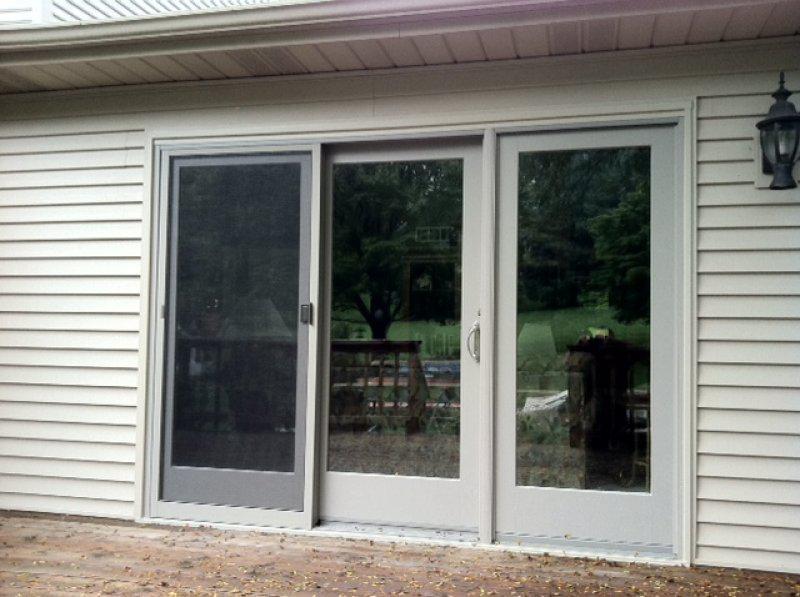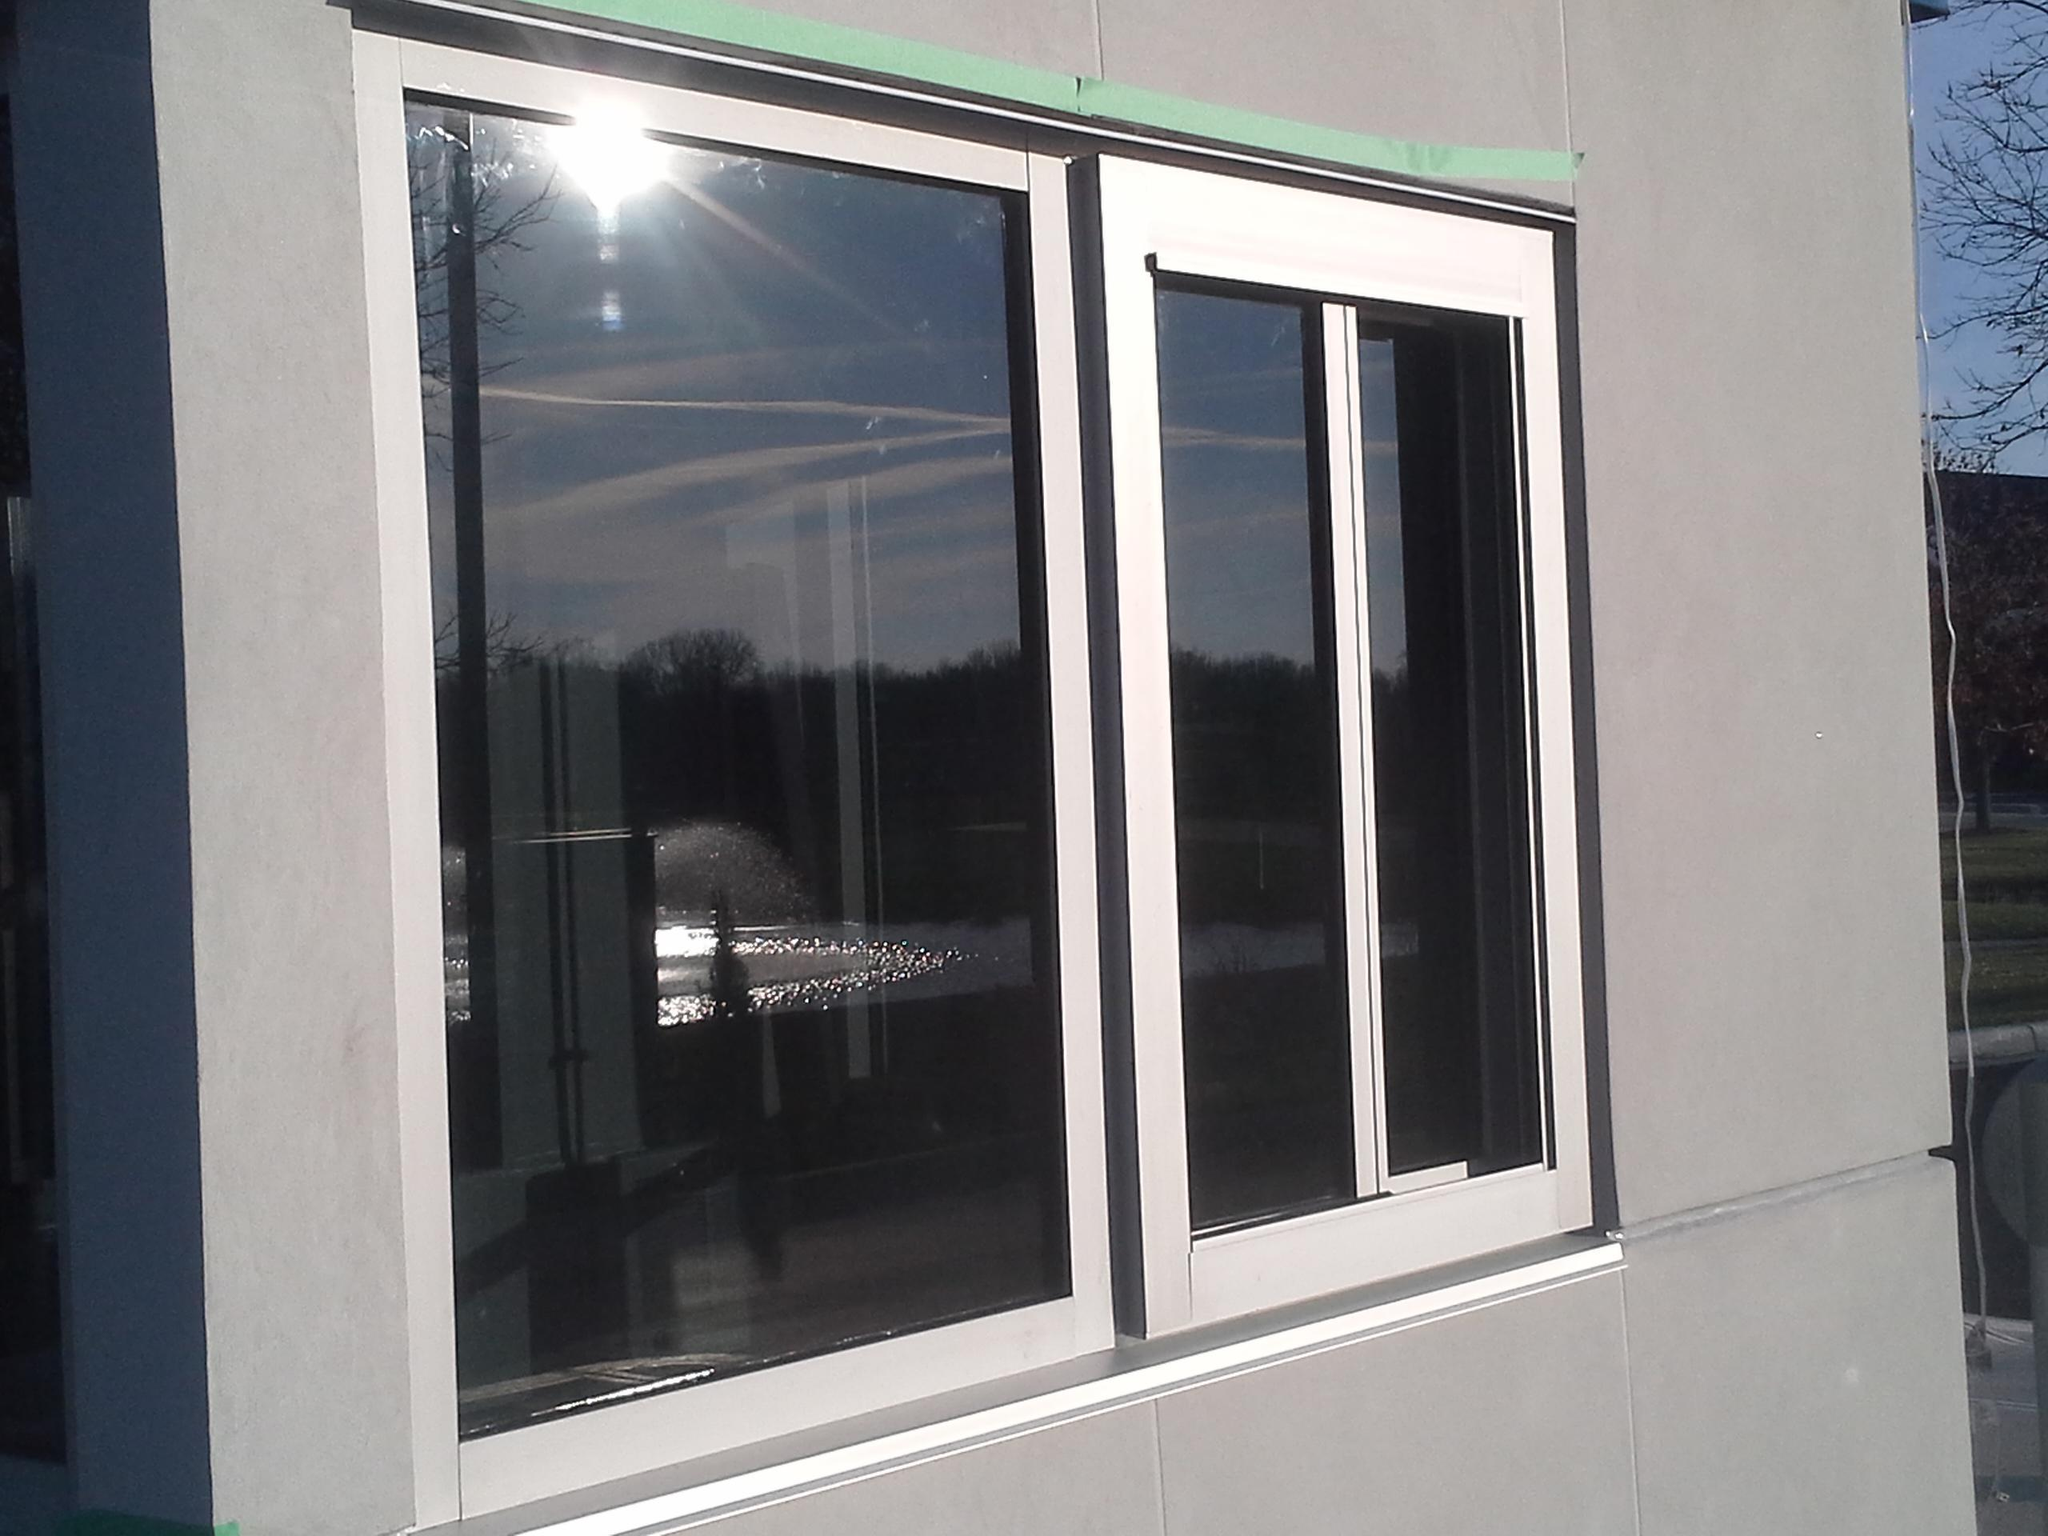The first image is the image on the left, the second image is the image on the right. Assess this claim about the two images: "Right image shows a sliding door unit with four door-shaped sections that don't have paned glass.". Correct or not? Answer yes or no. No. The first image is the image on the left, the second image is the image on the right. For the images displayed, is the sentence "A floor mat sits outside one of the doors." factually correct? Answer yes or no. No. 